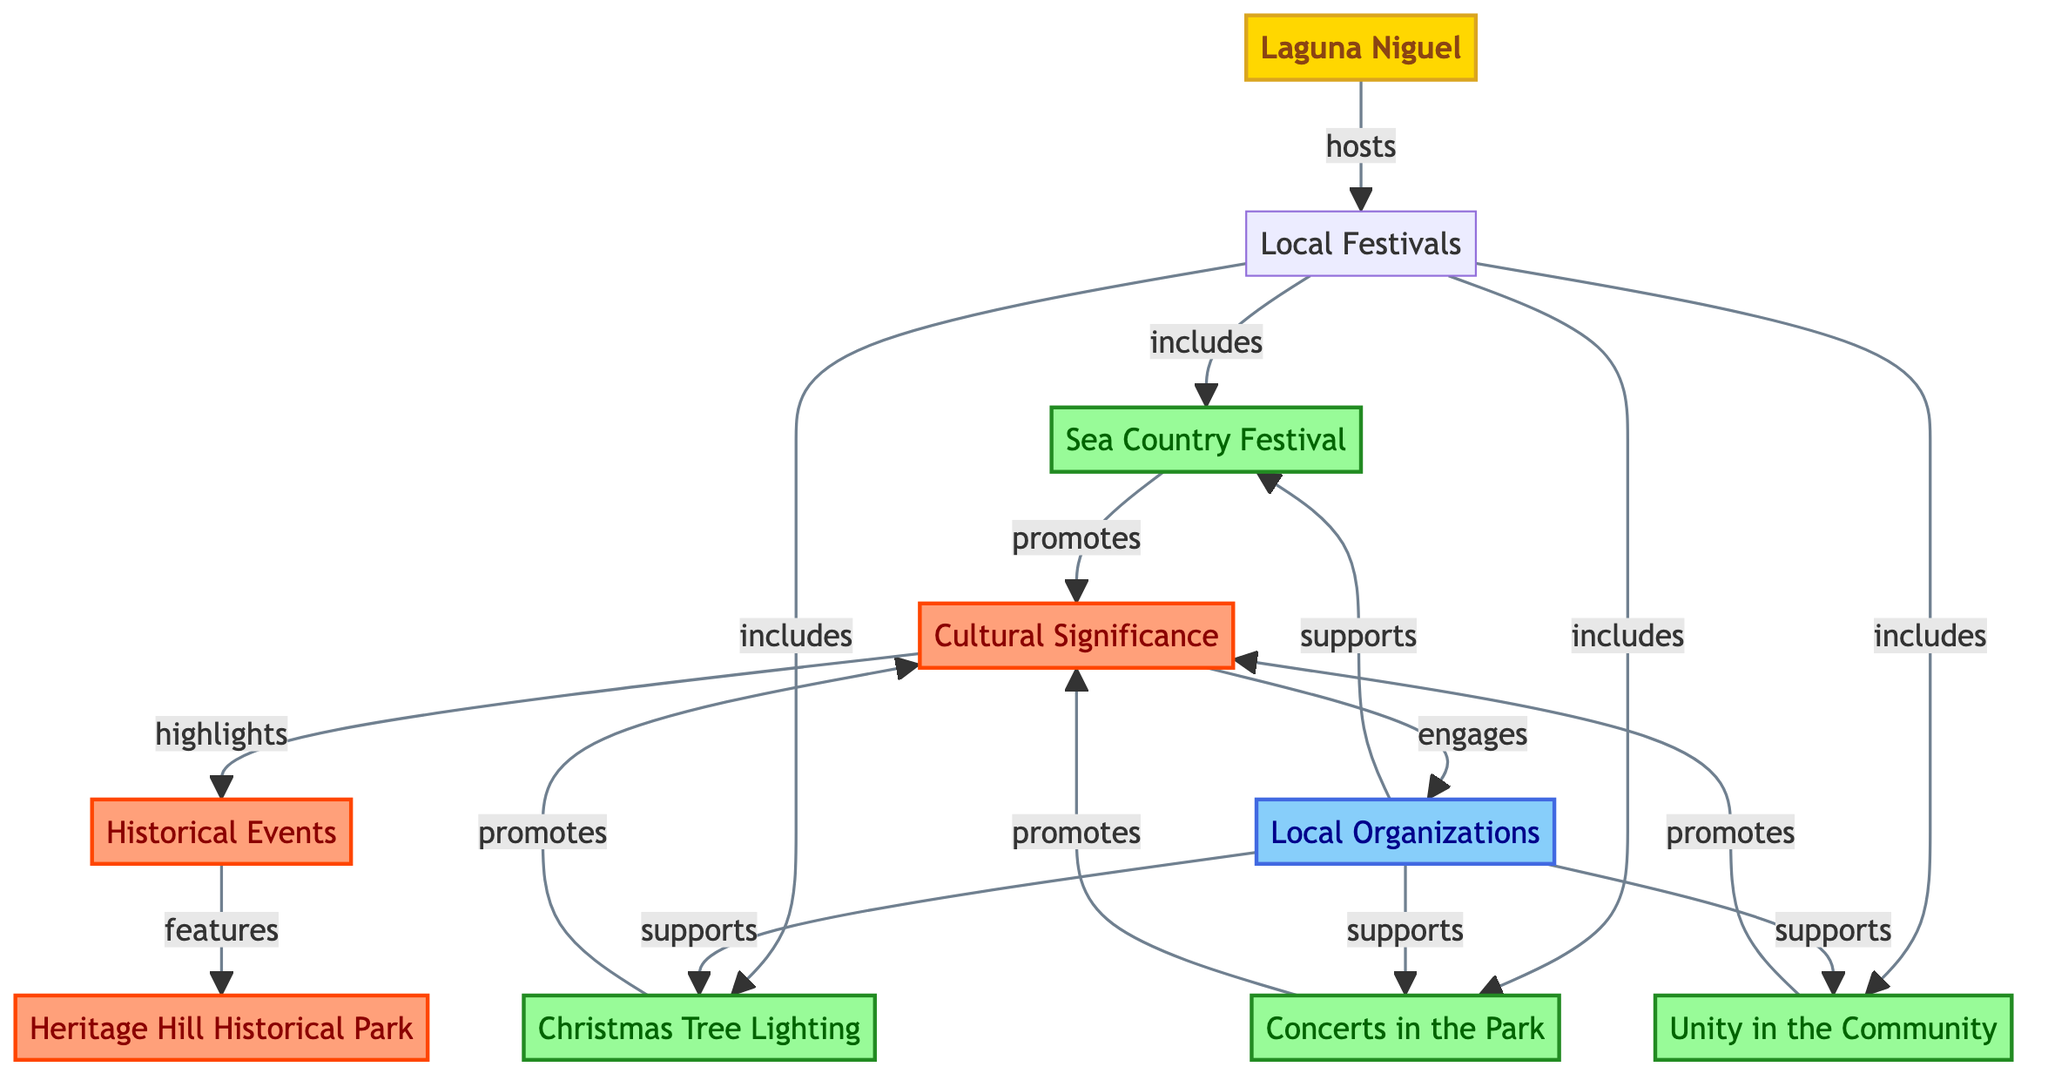What is the total number of nodes in the diagram? The diagram lists 10 nodes representing different elements related to Laguna Niguel's local festivals, including the city itself, the festivals, cultural significance, historical events, and local organizations. By simply counting these nodes, we confirm that there are indeed 10.
Answer: 10 Which festival is connected to “Cultural Significance”? Examining the connections in the diagram, we can see that all four festivals (Sea Country Festival, Christmas Tree Lighting, Concerts in the Park, Unity in the Community) are linked to the node labeled "Cultural Significance" via the “promotes” relationship. Therefore, each festival promotes cultural significance.
Answer: Sea Country Festival, Christmas Tree Lighting, Concerts in the Park, Unity in the Community What is the first local festival listed in the diagram? The diagram shows that the local festivals node directly connects to the Sea Country Festival first, as it appears directly after the node labeled "Local Festivals" in the diagram flow.
Answer: Sea Country Festival How many connections are there between local festivals and cultural significance? Each of the four local festivals connects to the "Cultural Significance" node through the “promotes” label. Therefore, there are a total of four connections between local festivals and the cultural significance.
Answer: 4 Which node features the “Historical Events”? Analyzing the connections in the diagram, we see that the “Historical Events” node is linked to the “Cultural Significance” node, which highlights its importance, indicating that every aspect of cultural significance reflects historical events.
Answer: Heritage Hill Historical Park What type of relationship exists between the “Local Organizations” and the festivals? The diagram shows that the local organizations support each individual festival through the “supports” relationship. Hence, the kind of relationship that exists is support.
Answer: supports How many local festivals are directly included under the “Local Festivals” node? The diagram clarifies that there are four distinct local festivals included under the “Local Festivals” node: Sea Country Festival, Christmas Tree Lighting, Concerts in the Park, and Unity in the Community. By counting these connections, we determine the total number of festivals.
Answer: 4 